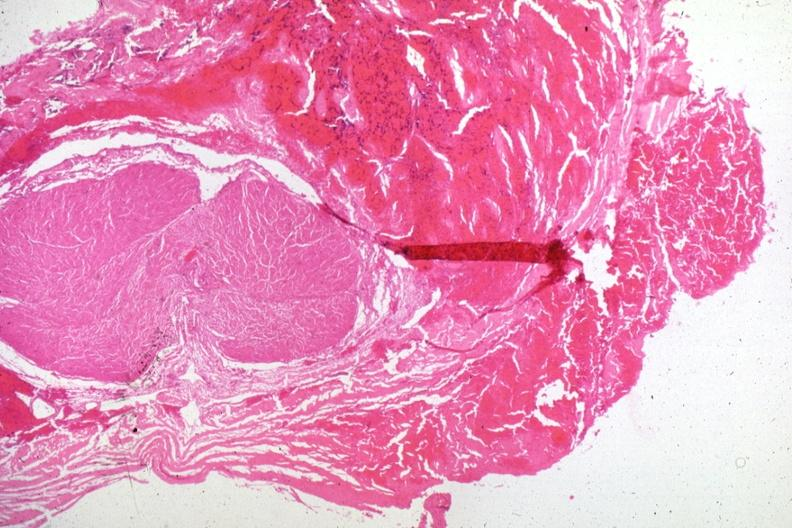s endocrine present?
Answer the question using a single word or phrase. Yes 